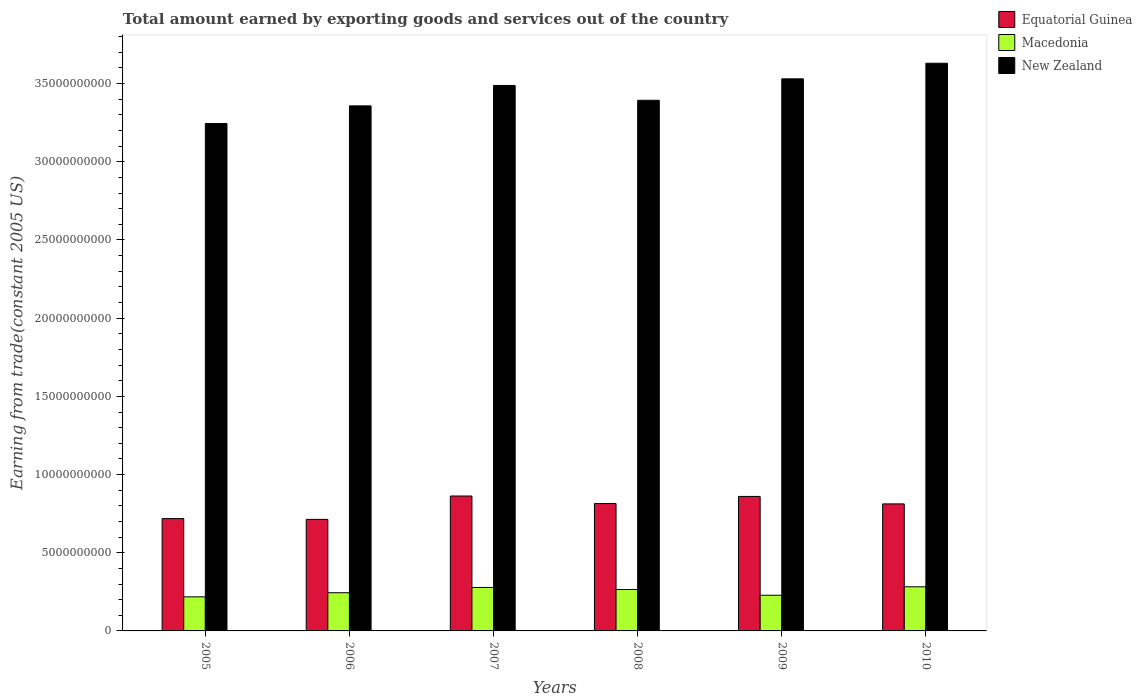How many groups of bars are there?
Your answer should be very brief. 6. Are the number of bars per tick equal to the number of legend labels?
Give a very brief answer. Yes. Are the number of bars on each tick of the X-axis equal?
Offer a very short reply. Yes. How many bars are there on the 3rd tick from the left?
Your answer should be compact. 3. What is the label of the 1st group of bars from the left?
Make the answer very short. 2005. In how many cases, is the number of bars for a given year not equal to the number of legend labels?
Offer a very short reply. 0. What is the total amount earned by exporting goods and services in Macedonia in 2007?
Make the answer very short. 2.78e+09. Across all years, what is the maximum total amount earned by exporting goods and services in New Zealand?
Provide a succinct answer. 3.63e+1. Across all years, what is the minimum total amount earned by exporting goods and services in Equatorial Guinea?
Offer a terse response. 7.13e+09. In which year was the total amount earned by exporting goods and services in Macedonia minimum?
Keep it short and to the point. 2005. What is the total total amount earned by exporting goods and services in Macedonia in the graph?
Your response must be concise. 1.52e+1. What is the difference between the total amount earned by exporting goods and services in New Zealand in 2007 and that in 2009?
Your answer should be compact. -4.24e+08. What is the difference between the total amount earned by exporting goods and services in New Zealand in 2007 and the total amount earned by exporting goods and services in Macedonia in 2009?
Your answer should be very brief. 3.26e+1. What is the average total amount earned by exporting goods and services in New Zealand per year?
Provide a succinct answer. 3.44e+1. In the year 2005, what is the difference between the total amount earned by exporting goods and services in New Zealand and total amount earned by exporting goods and services in Macedonia?
Offer a terse response. 3.03e+1. In how many years, is the total amount earned by exporting goods and services in Macedonia greater than 33000000000 US$?
Make the answer very short. 0. What is the ratio of the total amount earned by exporting goods and services in New Zealand in 2007 to that in 2009?
Give a very brief answer. 0.99. What is the difference between the highest and the second highest total amount earned by exporting goods and services in New Zealand?
Your response must be concise. 9.96e+08. What is the difference between the highest and the lowest total amount earned by exporting goods and services in Equatorial Guinea?
Make the answer very short. 1.50e+09. What does the 1st bar from the left in 2008 represents?
Offer a very short reply. Equatorial Guinea. What does the 3rd bar from the right in 2010 represents?
Keep it short and to the point. Equatorial Guinea. Is it the case that in every year, the sum of the total amount earned by exporting goods and services in New Zealand and total amount earned by exporting goods and services in Macedonia is greater than the total amount earned by exporting goods and services in Equatorial Guinea?
Keep it short and to the point. Yes. How many bars are there?
Your response must be concise. 18. Are all the bars in the graph horizontal?
Keep it short and to the point. No. What is the difference between two consecutive major ticks on the Y-axis?
Offer a terse response. 5.00e+09. Does the graph contain any zero values?
Your answer should be very brief. No. Does the graph contain grids?
Keep it short and to the point. No. Where does the legend appear in the graph?
Your response must be concise. Top right. How many legend labels are there?
Offer a very short reply. 3. How are the legend labels stacked?
Keep it short and to the point. Vertical. What is the title of the graph?
Offer a terse response. Total amount earned by exporting goods and services out of the country. Does "Caribbean small states" appear as one of the legend labels in the graph?
Your answer should be very brief. No. What is the label or title of the X-axis?
Your answer should be compact. Years. What is the label or title of the Y-axis?
Give a very brief answer. Earning from trade(constant 2005 US). What is the Earning from trade(constant 2005 US) in Equatorial Guinea in 2005?
Your answer should be compact. 7.18e+09. What is the Earning from trade(constant 2005 US) of Macedonia in 2005?
Offer a very short reply. 2.18e+09. What is the Earning from trade(constant 2005 US) of New Zealand in 2005?
Your answer should be very brief. 3.24e+1. What is the Earning from trade(constant 2005 US) in Equatorial Guinea in 2006?
Provide a short and direct response. 7.13e+09. What is the Earning from trade(constant 2005 US) in Macedonia in 2006?
Your answer should be very brief. 2.44e+09. What is the Earning from trade(constant 2005 US) of New Zealand in 2006?
Give a very brief answer. 3.36e+1. What is the Earning from trade(constant 2005 US) of Equatorial Guinea in 2007?
Offer a terse response. 8.63e+09. What is the Earning from trade(constant 2005 US) in Macedonia in 2007?
Provide a short and direct response. 2.78e+09. What is the Earning from trade(constant 2005 US) in New Zealand in 2007?
Provide a succinct answer. 3.49e+1. What is the Earning from trade(constant 2005 US) in Equatorial Guinea in 2008?
Your answer should be very brief. 8.15e+09. What is the Earning from trade(constant 2005 US) of Macedonia in 2008?
Your answer should be compact. 2.65e+09. What is the Earning from trade(constant 2005 US) of New Zealand in 2008?
Give a very brief answer. 3.39e+1. What is the Earning from trade(constant 2005 US) of Equatorial Guinea in 2009?
Make the answer very short. 8.60e+09. What is the Earning from trade(constant 2005 US) of Macedonia in 2009?
Offer a terse response. 2.28e+09. What is the Earning from trade(constant 2005 US) in New Zealand in 2009?
Provide a short and direct response. 3.53e+1. What is the Earning from trade(constant 2005 US) in Equatorial Guinea in 2010?
Keep it short and to the point. 8.12e+09. What is the Earning from trade(constant 2005 US) in Macedonia in 2010?
Ensure brevity in your answer.  2.82e+09. What is the Earning from trade(constant 2005 US) of New Zealand in 2010?
Provide a short and direct response. 3.63e+1. Across all years, what is the maximum Earning from trade(constant 2005 US) in Equatorial Guinea?
Provide a succinct answer. 8.63e+09. Across all years, what is the maximum Earning from trade(constant 2005 US) of Macedonia?
Keep it short and to the point. 2.82e+09. Across all years, what is the maximum Earning from trade(constant 2005 US) of New Zealand?
Your response must be concise. 3.63e+1. Across all years, what is the minimum Earning from trade(constant 2005 US) in Equatorial Guinea?
Offer a terse response. 7.13e+09. Across all years, what is the minimum Earning from trade(constant 2005 US) of Macedonia?
Ensure brevity in your answer.  2.18e+09. Across all years, what is the minimum Earning from trade(constant 2005 US) in New Zealand?
Provide a succinct answer. 3.24e+1. What is the total Earning from trade(constant 2005 US) of Equatorial Guinea in the graph?
Your answer should be very brief. 4.78e+1. What is the total Earning from trade(constant 2005 US) in Macedonia in the graph?
Provide a short and direct response. 1.52e+1. What is the total Earning from trade(constant 2005 US) of New Zealand in the graph?
Your answer should be very brief. 2.06e+11. What is the difference between the Earning from trade(constant 2005 US) of Equatorial Guinea in 2005 and that in 2006?
Your answer should be very brief. 5.07e+07. What is the difference between the Earning from trade(constant 2005 US) of Macedonia in 2005 and that in 2006?
Give a very brief answer. -2.64e+08. What is the difference between the Earning from trade(constant 2005 US) of New Zealand in 2005 and that in 2006?
Keep it short and to the point. -1.13e+09. What is the difference between the Earning from trade(constant 2005 US) of Equatorial Guinea in 2005 and that in 2007?
Keep it short and to the point. -1.44e+09. What is the difference between the Earning from trade(constant 2005 US) of Macedonia in 2005 and that in 2007?
Offer a very short reply. -6.01e+08. What is the difference between the Earning from trade(constant 2005 US) in New Zealand in 2005 and that in 2007?
Ensure brevity in your answer.  -2.43e+09. What is the difference between the Earning from trade(constant 2005 US) of Equatorial Guinea in 2005 and that in 2008?
Provide a short and direct response. -9.62e+08. What is the difference between the Earning from trade(constant 2005 US) of Macedonia in 2005 and that in 2008?
Your answer should be compact. -4.71e+08. What is the difference between the Earning from trade(constant 2005 US) in New Zealand in 2005 and that in 2008?
Your answer should be compact. -1.48e+09. What is the difference between the Earning from trade(constant 2005 US) of Equatorial Guinea in 2005 and that in 2009?
Provide a short and direct response. -1.42e+09. What is the difference between the Earning from trade(constant 2005 US) in Macedonia in 2005 and that in 2009?
Provide a short and direct response. -1.03e+08. What is the difference between the Earning from trade(constant 2005 US) in New Zealand in 2005 and that in 2009?
Offer a terse response. -2.86e+09. What is the difference between the Earning from trade(constant 2005 US) of Equatorial Guinea in 2005 and that in 2010?
Give a very brief answer. -9.39e+08. What is the difference between the Earning from trade(constant 2005 US) of Macedonia in 2005 and that in 2010?
Give a very brief answer. -6.44e+08. What is the difference between the Earning from trade(constant 2005 US) in New Zealand in 2005 and that in 2010?
Provide a short and direct response. -3.85e+09. What is the difference between the Earning from trade(constant 2005 US) of Equatorial Guinea in 2006 and that in 2007?
Offer a very short reply. -1.50e+09. What is the difference between the Earning from trade(constant 2005 US) in Macedonia in 2006 and that in 2007?
Provide a succinct answer. -3.37e+08. What is the difference between the Earning from trade(constant 2005 US) of New Zealand in 2006 and that in 2007?
Ensure brevity in your answer.  -1.31e+09. What is the difference between the Earning from trade(constant 2005 US) of Equatorial Guinea in 2006 and that in 2008?
Provide a succinct answer. -1.01e+09. What is the difference between the Earning from trade(constant 2005 US) in Macedonia in 2006 and that in 2008?
Provide a succinct answer. -2.07e+08. What is the difference between the Earning from trade(constant 2005 US) of New Zealand in 2006 and that in 2008?
Offer a very short reply. -3.55e+08. What is the difference between the Earning from trade(constant 2005 US) in Equatorial Guinea in 2006 and that in 2009?
Ensure brevity in your answer.  -1.47e+09. What is the difference between the Earning from trade(constant 2005 US) of Macedonia in 2006 and that in 2009?
Offer a very short reply. 1.61e+08. What is the difference between the Earning from trade(constant 2005 US) of New Zealand in 2006 and that in 2009?
Your response must be concise. -1.73e+09. What is the difference between the Earning from trade(constant 2005 US) in Equatorial Guinea in 2006 and that in 2010?
Make the answer very short. -9.90e+08. What is the difference between the Earning from trade(constant 2005 US) of Macedonia in 2006 and that in 2010?
Give a very brief answer. -3.79e+08. What is the difference between the Earning from trade(constant 2005 US) in New Zealand in 2006 and that in 2010?
Your answer should be compact. -2.72e+09. What is the difference between the Earning from trade(constant 2005 US) in Equatorial Guinea in 2007 and that in 2008?
Your answer should be compact. 4.83e+08. What is the difference between the Earning from trade(constant 2005 US) of Macedonia in 2007 and that in 2008?
Your answer should be compact. 1.30e+08. What is the difference between the Earning from trade(constant 2005 US) in New Zealand in 2007 and that in 2008?
Your answer should be very brief. 9.50e+08. What is the difference between the Earning from trade(constant 2005 US) in Equatorial Guinea in 2007 and that in 2009?
Keep it short and to the point. 2.73e+07. What is the difference between the Earning from trade(constant 2005 US) in Macedonia in 2007 and that in 2009?
Provide a short and direct response. 4.98e+08. What is the difference between the Earning from trade(constant 2005 US) in New Zealand in 2007 and that in 2009?
Offer a very short reply. -4.24e+08. What is the difference between the Earning from trade(constant 2005 US) of Equatorial Guinea in 2007 and that in 2010?
Give a very brief answer. 5.05e+08. What is the difference between the Earning from trade(constant 2005 US) in Macedonia in 2007 and that in 2010?
Give a very brief answer. -4.25e+07. What is the difference between the Earning from trade(constant 2005 US) of New Zealand in 2007 and that in 2010?
Offer a terse response. -1.42e+09. What is the difference between the Earning from trade(constant 2005 US) in Equatorial Guinea in 2008 and that in 2009?
Give a very brief answer. -4.56e+08. What is the difference between the Earning from trade(constant 2005 US) of Macedonia in 2008 and that in 2009?
Make the answer very short. 3.68e+08. What is the difference between the Earning from trade(constant 2005 US) in New Zealand in 2008 and that in 2009?
Ensure brevity in your answer.  -1.37e+09. What is the difference between the Earning from trade(constant 2005 US) of Equatorial Guinea in 2008 and that in 2010?
Your answer should be very brief. 2.22e+07. What is the difference between the Earning from trade(constant 2005 US) in Macedonia in 2008 and that in 2010?
Ensure brevity in your answer.  -1.72e+08. What is the difference between the Earning from trade(constant 2005 US) of New Zealand in 2008 and that in 2010?
Your answer should be very brief. -2.37e+09. What is the difference between the Earning from trade(constant 2005 US) in Equatorial Guinea in 2009 and that in 2010?
Provide a succinct answer. 4.78e+08. What is the difference between the Earning from trade(constant 2005 US) in Macedonia in 2009 and that in 2010?
Provide a short and direct response. -5.40e+08. What is the difference between the Earning from trade(constant 2005 US) in New Zealand in 2009 and that in 2010?
Your answer should be compact. -9.96e+08. What is the difference between the Earning from trade(constant 2005 US) of Equatorial Guinea in 2005 and the Earning from trade(constant 2005 US) of Macedonia in 2006?
Provide a short and direct response. 4.74e+09. What is the difference between the Earning from trade(constant 2005 US) in Equatorial Guinea in 2005 and the Earning from trade(constant 2005 US) in New Zealand in 2006?
Offer a very short reply. -2.64e+1. What is the difference between the Earning from trade(constant 2005 US) in Macedonia in 2005 and the Earning from trade(constant 2005 US) in New Zealand in 2006?
Give a very brief answer. -3.14e+1. What is the difference between the Earning from trade(constant 2005 US) of Equatorial Guinea in 2005 and the Earning from trade(constant 2005 US) of Macedonia in 2007?
Keep it short and to the point. 4.40e+09. What is the difference between the Earning from trade(constant 2005 US) of Equatorial Guinea in 2005 and the Earning from trade(constant 2005 US) of New Zealand in 2007?
Your answer should be compact. -2.77e+1. What is the difference between the Earning from trade(constant 2005 US) in Macedonia in 2005 and the Earning from trade(constant 2005 US) in New Zealand in 2007?
Provide a succinct answer. -3.27e+1. What is the difference between the Earning from trade(constant 2005 US) in Equatorial Guinea in 2005 and the Earning from trade(constant 2005 US) in Macedonia in 2008?
Your answer should be very brief. 4.53e+09. What is the difference between the Earning from trade(constant 2005 US) of Equatorial Guinea in 2005 and the Earning from trade(constant 2005 US) of New Zealand in 2008?
Give a very brief answer. -2.67e+1. What is the difference between the Earning from trade(constant 2005 US) in Macedonia in 2005 and the Earning from trade(constant 2005 US) in New Zealand in 2008?
Your response must be concise. -3.18e+1. What is the difference between the Earning from trade(constant 2005 US) in Equatorial Guinea in 2005 and the Earning from trade(constant 2005 US) in Macedonia in 2009?
Your response must be concise. 4.90e+09. What is the difference between the Earning from trade(constant 2005 US) in Equatorial Guinea in 2005 and the Earning from trade(constant 2005 US) in New Zealand in 2009?
Keep it short and to the point. -2.81e+1. What is the difference between the Earning from trade(constant 2005 US) in Macedonia in 2005 and the Earning from trade(constant 2005 US) in New Zealand in 2009?
Make the answer very short. -3.31e+1. What is the difference between the Earning from trade(constant 2005 US) of Equatorial Guinea in 2005 and the Earning from trade(constant 2005 US) of Macedonia in 2010?
Ensure brevity in your answer.  4.36e+09. What is the difference between the Earning from trade(constant 2005 US) in Equatorial Guinea in 2005 and the Earning from trade(constant 2005 US) in New Zealand in 2010?
Offer a terse response. -2.91e+1. What is the difference between the Earning from trade(constant 2005 US) in Macedonia in 2005 and the Earning from trade(constant 2005 US) in New Zealand in 2010?
Provide a short and direct response. -3.41e+1. What is the difference between the Earning from trade(constant 2005 US) of Equatorial Guinea in 2006 and the Earning from trade(constant 2005 US) of Macedonia in 2007?
Offer a very short reply. 4.35e+09. What is the difference between the Earning from trade(constant 2005 US) of Equatorial Guinea in 2006 and the Earning from trade(constant 2005 US) of New Zealand in 2007?
Offer a very short reply. -2.78e+1. What is the difference between the Earning from trade(constant 2005 US) in Macedonia in 2006 and the Earning from trade(constant 2005 US) in New Zealand in 2007?
Your response must be concise. -3.24e+1. What is the difference between the Earning from trade(constant 2005 US) of Equatorial Guinea in 2006 and the Earning from trade(constant 2005 US) of Macedonia in 2008?
Your answer should be compact. 4.48e+09. What is the difference between the Earning from trade(constant 2005 US) in Equatorial Guinea in 2006 and the Earning from trade(constant 2005 US) in New Zealand in 2008?
Your response must be concise. -2.68e+1. What is the difference between the Earning from trade(constant 2005 US) of Macedonia in 2006 and the Earning from trade(constant 2005 US) of New Zealand in 2008?
Provide a succinct answer. -3.15e+1. What is the difference between the Earning from trade(constant 2005 US) in Equatorial Guinea in 2006 and the Earning from trade(constant 2005 US) in Macedonia in 2009?
Give a very brief answer. 4.85e+09. What is the difference between the Earning from trade(constant 2005 US) in Equatorial Guinea in 2006 and the Earning from trade(constant 2005 US) in New Zealand in 2009?
Your response must be concise. -2.82e+1. What is the difference between the Earning from trade(constant 2005 US) in Macedonia in 2006 and the Earning from trade(constant 2005 US) in New Zealand in 2009?
Give a very brief answer. -3.29e+1. What is the difference between the Earning from trade(constant 2005 US) in Equatorial Guinea in 2006 and the Earning from trade(constant 2005 US) in Macedonia in 2010?
Give a very brief answer. 4.31e+09. What is the difference between the Earning from trade(constant 2005 US) in Equatorial Guinea in 2006 and the Earning from trade(constant 2005 US) in New Zealand in 2010?
Ensure brevity in your answer.  -2.92e+1. What is the difference between the Earning from trade(constant 2005 US) of Macedonia in 2006 and the Earning from trade(constant 2005 US) of New Zealand in 2010?
Provide a succinct answer. -3.39e+1. What is the difference between the Earning from trade(constant 2005 US) of Equatorial Guinea in 2007 and the Earning from trade(constant 2005 US) of Macedonia in 2008?
Your response must be concise. 5.98e+09. What is the difference between the Earning from trade(constant 2005 US) in Equatorial Guinea in 2007 and the Earning from trade(constant 2005 US) in New Zealand in 2008?
Provide a short and direct response. -2.53e+1. What is the difference between the Earning from trade(constant 2005 US) of Macedonia in 2007 and the Earning from trade(constant 2005 US) of New Zealand in 2008?
Make the answer very short. -3.12e+1. What is the difference between the Earning from trade(constant 2005 US) of Equatorial Guinea in 2007 and the Earning from trade(constant 2005 US) of Macedonia in 2009?
Give a very brief answer. 6.35e+09. What is the difference between the Earning from trade(constant 2005 US) in Equatorial Guinea in 2007 and the Earning from trade(constant 2005 US) in New Zealand in 2009?
Give a very brief answer. -2.67e+1. What is the difference between the Earning from trade(constant 2005 US) in Macedonia in 2007 and the Earning from trade(constant 2005 US) in New Zealand in 2009?
Make the answer very short. -3.25e+1. What is the difference between the Earning from trade(constant 2005 US) in Equatorial Guinea in 2007 and the Earning from trade(constant 2005 US) in Macedonia in 2010?
Give a very brief answer. 5.81e+09. What is the difference between the Earning from trade(constant 2005 US) of Equatorial Guinea in 2007 and the Earning from trade(constant 2005 US) of New Zealand in 2010?
Ensure brevity in your answer.  -2.77e+1. What is the difference between the Earning from trade(constant 2005 US) in Macedonia in 2007 and the Earning from trade(constant 2005 US) in New Zealand in 2010?
Give a very brief answer. -3.35e+1. What is the difference between the Earning from trade(constant 2005 US) of Equatorial Guinea in 2008 and the Earning from trade(constant 2005 US) of Macedonia in 2009?
Your answer should be very brief. 5.86e+09. What is the difference between the Earning from trade(constant 2005 US) of Equatorial Guinea in 2008 and the Earning from trade(constant 2005 US) of New Zealand in 2009?
Provide a short and direct response. -2.72e+1. What is the difference between the Earning from trade(constant 2005 US) of Macedonia in 2008 and the Earning from trade(constant 2005 US) of New Zealand in 2009?
Ensure brevity in your answer.  -3.27e+1. What is the difference between the Earning from trade(constant 2005 US) in Equatorial Guinea in 2008 and the Earning from trade(constant 2005 US) in Macedonia in 2010?
Keep it short and to the point. 5.32e+09. What is the difference between the Earning from trade(constant 2005 US) of Equatorial Guinea in 2008 and the Earning from trade(constant 2005 US) of New Zealand in 2010?
Your answer should be very brief. -2.82e+1. What is the difference between the Earning from trade(constant 2005 US) of Macedonia in 2008 and the Earning from trade(constant 2005 US) of New Zealand in 2010?
Offer a terse response. -3.37e+1. What is the difference between the Earning from trade(constant 2005 US) in Equatorial Guinea in 2009 and the Earning from trade(constant 2005 US) in Macedonia in 2010?
Make the answer very short. 5.78e+09. What is the difference between the Earning from trade(constant 2005 US) of Equatorial Guinea in 2009 and the Earning from trade(constant 2005 US) of New Zealand in 2010?
Your response must be concise. -2.77e+1. What is the difference between the Earning from trade(constant 2005 US) in Macedonia in 2009 and the Earning from trade(constant 2005 US) in New Zealand in 2010?
Your answer should be very brief. -3.40e+1. What is the average Earning from trade(constant 2005 US) of Equatorial Guinea per year?
Provide a succinct answer. 7.97e+09. What is the average Earning from trade(constant 2005 US) in Macedonia per year?
Your answer should be compact. 2.53e+09. What is the average Earning from trade(constant 2005 US) of New Zealand per year?
Keep it short and to the point. 3.44e+1. In the year 2005, what is the difference between the Earning from trade(constant 2005 US) of Equatorial Guinea and Earning from trade(constant 2005 US) of Macedonia?
Your answer should be very brief. 5.00e+09. In the year 2005, what is the difference between the Earning from trade(constant 2005 US) of Equatorial Guinea and Earning from trade(constant 2005 US) of New Zealand?
Provide a succinct answer. -2.53e+1. In the year 2005, what is the difference between the Earning from trade(constant 2005 US) in Macedonia and Earning from trade(constant 2005 US) in New Zealand?
Your response must be concise. -3.03e+1. In the year 2006, what is the difference between the Earning from trade(constant 2005 US) of Equatorial Guinea and Earning from trade(constant 2005 US) of Macedonia?
Keep it short and to the point. 4.69e+09. In the year 2006, what is the difference between the Earning from trade(constant 2005 US) of Equatorial Guinea and Earning from trade(constant 2005 US) of New Zealand?
Make the answer very short. -2.64e+1. In the year 2006, what is the difference between the Earning from trade(constant 2005 US) of Macedonia and Earning from trade(constant 2005 US) of New Zealand?
Make the answer very short. -3.11e+1. In the year 2007, what is the difference between the Earning from trade(constant 2005 US) of Equatorial Guinea and Earning from trade(constant 2005 US) of Macedonia?
Your answer should be compact. 5.85e+09. In the year 2007, what is the difference between the Earning from trade(constant 2005 US) in Equatorial Guinea and Earning from trade(constant 2005 US) in New Zealand?
Provide a succinct answer. -2.63e+1. In the year 2007, what is the difference between the Earning from trade(constant 2005 US) in Macedonia and Earning from trade(constant 2005 US) in New Zealand?
Your response must be concise. -3.21e+1. In the year 2008, what is the difference between the Earning from trade(constant 2005 US) of Equatorial Guinea and Earning from trade(constant 2005 US) of Macedonia?
Your answer should be very brief. 5.50e+09. In the year 2008, what is the difference between the Earning from trade(constant 2005 US) in Equatorial Guinea and Earning from trade(constant 2005 US) in New Zealand?
Your answer should be compact. -2.58e+1. In the year 2008, what is the difference between the Earning from trade(constant 2005 US) of Macedonia and Earning from trade(constant 2005 US) of New Zealand?
Keep it short and to the point. -3.13e+1. In the year 2009, what is the difference between the Earning from trade(constant 2005 US) of Equatorial Guinea and Earning from trade(constant 2005 US) of Macedonia?
Keep it short and to the point. 6.32e+09. In the year 2009, what is the difference between the Earning from trade(constant 2005 US) of Equatorial Guinea and Earning from trade(constant 2005 US) of New Zealand?
Make the answer very short. -2.67e+1. In the year 2009, what is the difference between the Earning from trade(constant 2005 US) of Macedonia and Earning from trade(constant 2005 US) of New Zealand?
Offer a very short reply. -3.30e+1. In the year 2010, what is the difference between the Earning from trade(constant 2005 US) of Equatorial Guinea and Earning from trade(constant 2005 US) of Macedonia?
Ensure brevity in your answer.  5.30e+09. In the year 2010, what is the difference between the Earning from trade(constant 2005 US) in Equatorial Guinea and Earning from trade(constant 2005 US) in New Zealand?
Ensure brevity in your answer.  -2.82e+1. In the year 2010, what is the difference between the Earning from trade(constant 2005 US) in Macedonia and Earning from trade(constant 2005 US) in New Zealand?
Keep it short and to the point. -3.35e+1. What is the ratio of the Earning from trade(constant 2005 US) in Equatorial Guinea in 2005 to that in 2006?
Ensure brevity in your answer.  1.01. What is the ratio of the Earning from trade(constant 2005 US) in Macedonia in 2005 to that in 2006?
Your answer should be very brief. 0.89. What is the ratio of the Earning from trade(constant 2005 US) of New Zealand in 2005 to that in 2006?
Provide a succinct answer. 0.97. What is the ratio of the Earning from trade(constant 2005 US) in Equatorial Guinea in 2005 to that in 2007?
Your answer should be compact. 0.83. What is the ratio of the Earning from trade(constant 2005 US) of Macedonia in 2005 to that in 2007?
Give a very brief answer. 0.78. What is the ratio of the Earning from trade(constant 2005 US) in New Zealand in 2005 to that in 2007?
Make the answer very short. 0.93. What is the ratio of the Earning from trade(constant 2005 US) of Equatorial Guinea in 2005 to that in 2008?
Offer a terse response. 0.88. What is the ratio of the Earning from trade(constant 2005 US) of Macedonia in 2005 to that in 2008?
Ensure brevity in your answer.  0.82. What is the ratio of the Earning from trade(constant 2005 US) in New Zealand in 2005 to that in 2008?
Make the answer very short. 0.96. What is the ratio of the Earning from trade(constant 2005 US) of Equatorial Guinea in 2005 to that in 2009?
Offer a terse response. 0.84. What is the ratio of the Earning from trade(constant 2005 US) in Macedonia in 2005 to that in 2009?
Ensure brevity in your answer.  0.95. What is the ratio of the Earning from trade(constant 2005 US) of New Zealand in 2005 to that in 2009?
Offer a terse response. 0.92. What is the ratio of the Earning from trade(constant 2005 US) of Equatorial Guinea in 2005 to that in 2010?
Provide a succinct answer. 0.88. What is the ratio of the Earning from trade(constant 2005 US) in Macedonia in 2005 to that in 2010?
Your answer should be compact. 0.77. What is the ratio of the Earning from trade(constant 2005 US) of New Zealand in 2005 to that in 2010?
Offer a terse response. 0.89. What is the ratio of the Earning from trade(constant 2005 US) of Equatorial Guinea in 2006 to that in 2007?
Give a very brief answer. 0.83. What is the ratio of the Earning from trade(constant 2005 US) of Macedonia in 2006 to that in 2007?
Make the answer very short. 0.88. What is the ratio of the Earning from trade(constant 2005 US) in New Zealand in 2006 to that in 2007?
Offer a terse response. 0.96. What is the ratio of the Earning from trade(constant 2005 US) in Equatorial Guinea in 2006 to that in 2008?
Keep it short and to the point. 0.88. What is the ratio of the Earning from trade(constant 2005 US) of Macedonia in 2006 to that in 2008?
Your answer should be compact. 0.92. What is the ratio of the Earning from trade(constant 2005 US) in New Zealand in 2006 to that in 2008?
Provide a short and direct response. 0.99. What is the ratio of the Earning from trade(constant 2005 US) of Equatorial Guinea in 2006 to that in 2009?
Keep it short and to the point. 0.83. What is the ratio of the Earning from trade(constant 2005 US) of Macedonia in 2006 to that in 2009?
Provide a short and direct response. 1.07. What is the ratio of the Earning from trade(constant 2005 US) in New Zealand in 2006 to that in 2009?
Keep it short and to the point. 0.95. What is the ratio of the Earning from trade(constant 2005 US) of Equatorial Guinea in 2006 to that in 2010?
Offer a very short reply. 0.88. What is the ratio of the Earning from trade(constant 2005 US) of Macedonia in 2006 to that in 2010?
Make the answer very short. 0.87. What is the ratio of the Earning from trade(constant 2005 US) in New Zealand in 2006 to that in 2010?
Offer a terse response. 0.92. What is the ratio of the Earning from trade(constant 2005 US) of Equatorial Guinea in 2007 to that in 2008?
Offer a very short reply. 1.06. What is the ratio of the Earning from trade(constant 2005 US) in Macedonia in 2007 to that in 2008?
Keep it short and to the point. 1.05. What is the ratio of the Earning from trade(constant 2005 US) in New Zealand in 2007 to that in 2008?
Give a very brief answer. 1.03. What is the ratio of the Earning from trade(constant 2005 US) of Macedonia in 2007 to that in 2009?
Ensure brevity in your answer.  1.22. What is the ratio of the Earning from trade(constant 2005 US) of New Zealand in 2007 to that in 2009?
Give a very brief answer. 0.99. What is the ratio of the Earning from trade(constant 2005 US) in Equatorial Guinea in 2007 to that in 2010?
Keep it short and to the point. 1.06. What is the ratio of the Earning from trade(constant 2005 US) in Macedonia in 2007 to that in 2010?
Offer a terse response. 0.98. What is the ratio of the Earning from trade(constant 2005 US) of New Zealand in 2007 to that in 2010?
Give a very brief answer. 0.96. What is the ratio of the Earning from trade(constant 2005 US) of Equatorial Guinea in 2008 to that in 2009?
Ensure brevity in your answer.  0.95. What is the ratio of the Earning from trade(constant 2005 US) in Macedonia in 2008 to that in 2009?
Your response must be concise. 1.16. What is the ratio of the Earning from trade(constant 2005 US) of New Zealand in 2008 to that in 2009?
Your answer should be compact. 0.96. What is the ratio of the Earning from trade(constant 2005 US) in Macedonia in 2008 to that in 2010?
Make the answer very short. 0.94. What is the ratio of the Earning from trade(constant 2005 US) of New Zealand in 2008 to that in 2010?
Your response must be concise. 0.93. What is the ratio of the Earning from trade(constant 2005 US) in Equatorial Guinea in 2009 to that in 2010?
Provide a short and direct response. 1.06. What is the ratio of the Earning from trade(constant 2005 US) of Macedonia in 2009 to that in 2010?
Your answer should be very brief. 0.81. What is the ratio of the Earning from trade(constant 2005 US) of New Zealand in 2009 to that in 2010?
Make the answer very short. 0.97. What is the difference between the highest and the second highest Earning from trade(constant 2005 US) in Equatorial Guinea?
Your answer should be very brief. 2.73e+07. What is the difference between the highest and the second highest Earning from trade(constant 2005 US) in Macedonia?
Keep it short and to the point. 4.25e+07. What is the difference between the highest and the second highest Earning from trade(constant 2005 US) of New Zealand?
Give a very brief answer. 9.96e+08. What is the difference between the highest and the lowest Earning from trade(constant 2005 US) in Equatorial Guinea?
Provide a succinct answer. 1.50e+09. What is the difference between the highest and the lowest Earning from trade(constant 2005 US) of Macedonia?
Your response must be concise. 6.44e+08. What is the difference between the highest and the lowest Earning from trade(constant 2005 US) in New Zealand?
Your answer should be very brief. 3.85e+09. 